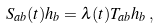Convert formula to latex. <formula><loc_0><loc_0><loc_500><loc_500>S _ { a b } ( t ) h _ { b } = \lambda ( t ) T _ { a b } h _ { b } \, ,</formula> 